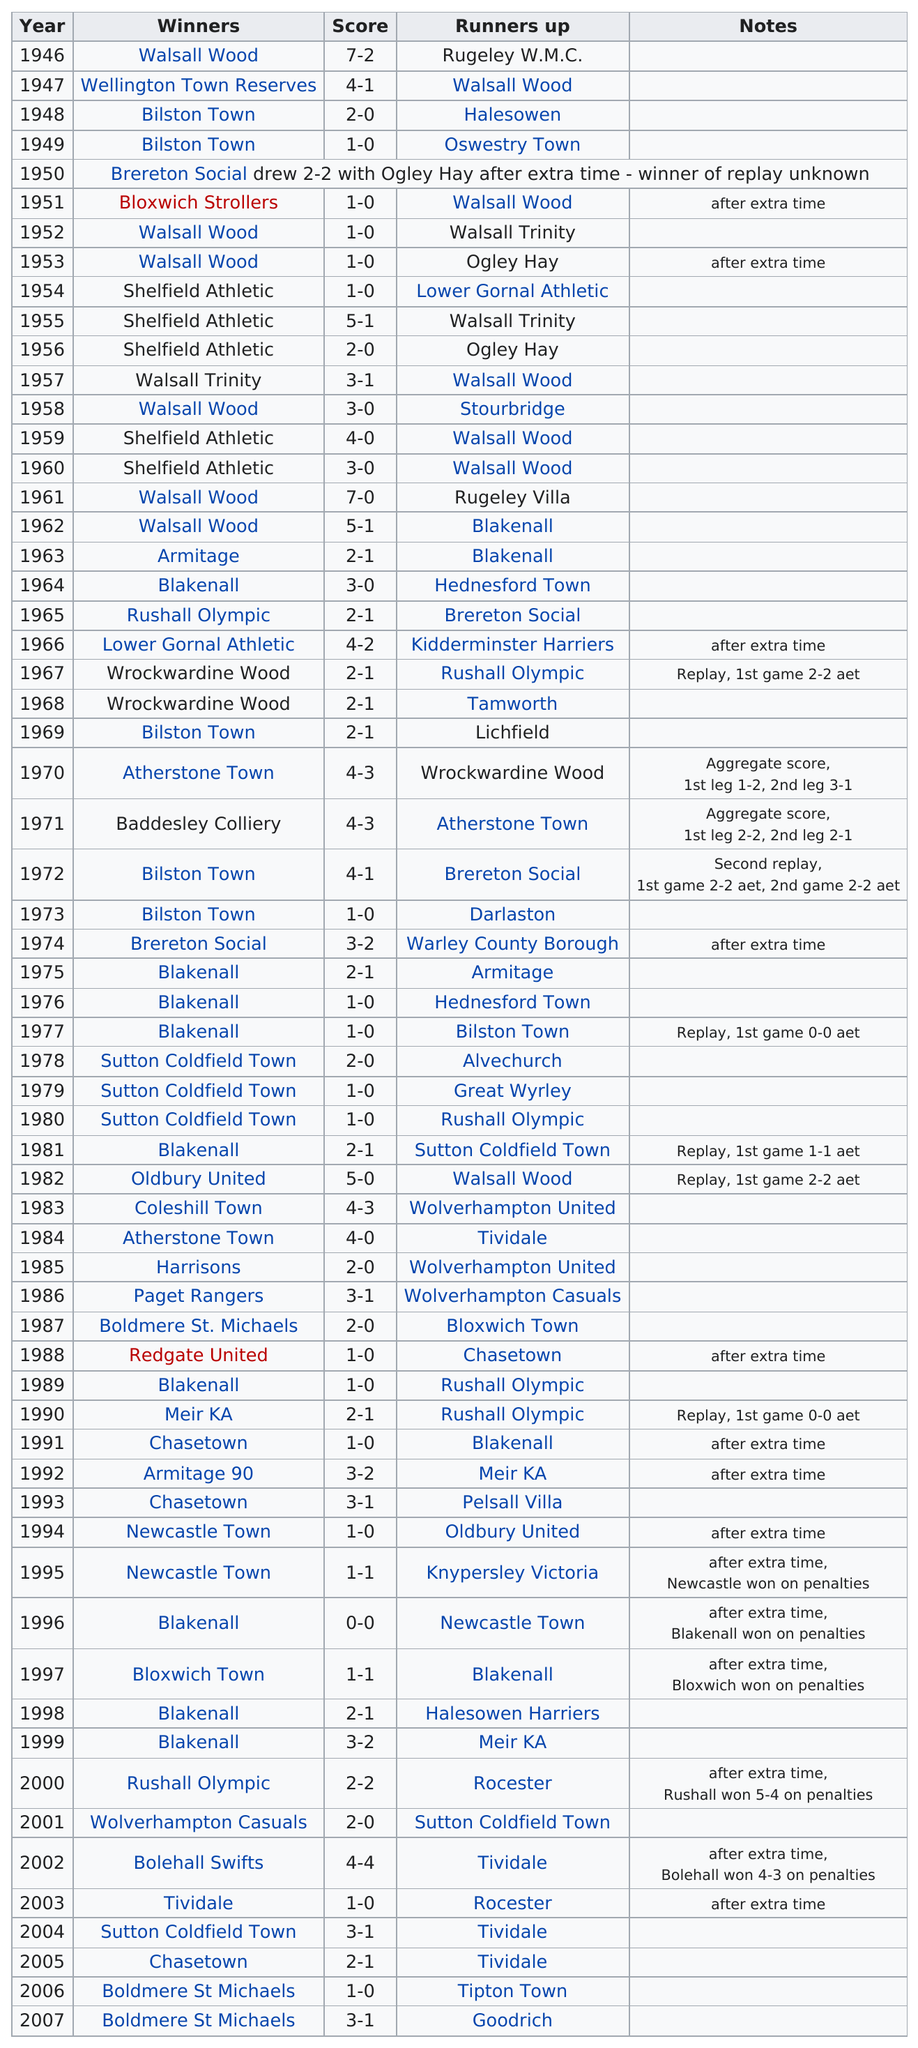Highlight a few significant elements in this photo. Out of the teams that won at least three games during the 1970s, Blakenall was one of them. Chasetown last won in the year 2005. Shelfield Athletic won a total of 5 finals. Walsall Wood was the runner-up the most times between 1950 and 1960. Walsall Wood was the winner of the first final. 